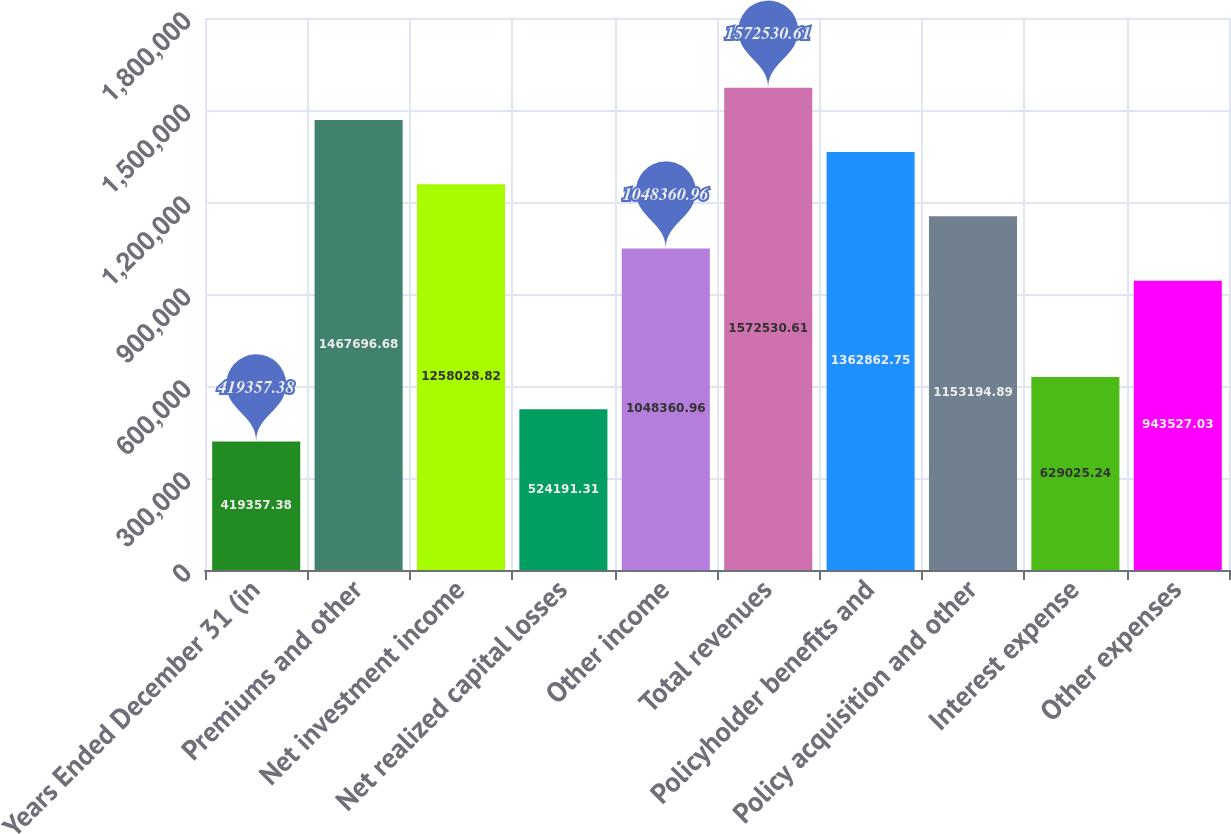Convert chart to OTSL. <chart><loc_0><loc_0><loc_500><loc_500><bar_chart><fcel>Years Ended December 31 (in<fcel>Premiums and other<fcel>Net investment income<fcel>Net realized capital losses<fcel>Other income<fcel>Total revenues<fcel>Policyholder benefits and<fcel>Policy acquisition and other<fcel>Interest expense<fcel>Other expenses<nl><fcel>419357<fcel>1.4677e+06<fcel>1.25803e+06<fcel>524191<fcel>1.04836e+06<fcel>1.57253e+06<fcel>1.36286e+06<fcel>1.15319e+06<fcel>629025<fcel>943527<nl></chart> 